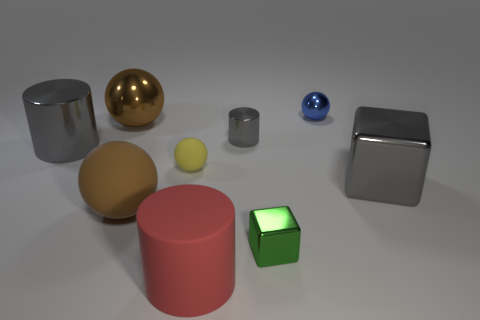There is a green metallic object that is on the right side of the big gray object left of the brown rubber object; how big is it?
Provide a short and direct response. Small. Do the green metal thing and the brown shiny ball have the same size?
Provide a short and direct response. No. There is a large brown sphere that is in front of the large gray object right of the yellow sphere; is there a big gray metal cylinder to the right of it?
Provide a short and direct response. No. What size is the brown metallic sphere?
Give a very brief answer. Large. How many rubber cylinders are the same size as the gray cube?
Provide a short and direct response. 1. There is another large thing that is the same shape as the large red thing; what is it made of?
Offer a terse response. Metal. There is a gray object that is both behind the tiny rubber sphere and on the right side of the red object; what shape is it?
Keep it short and to the point. Cylinder. What is the shape of the big gray object on the left side of the large red cylinder?
Give a very brief answer. Cylinder. What number of big things are on the left side of the tiny cube and on the right side of the tiny yellow sphere?
Your answer should be compact. 1. There is a blue sphere; is its size the same as the block that is on the left side of the blue object?
Provide a short and direct response. Yes. 